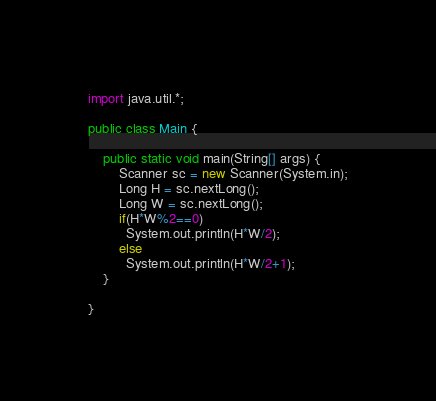Convert code to text. <code><loc_0><loc_0><loc_500><loc_500><_Java_>import java.util.*;

public class Main {

    public static void main(String[] args) {
        Scanner sc = new Scanner(System.in);
        Long H = sc.nextLong();
        Long W = sc.nextLong();
        if(H*W%2==0)
          System.out.println(H*W/2);
        else
          System.out.println(H*W/2+1);
    }

}</code> 